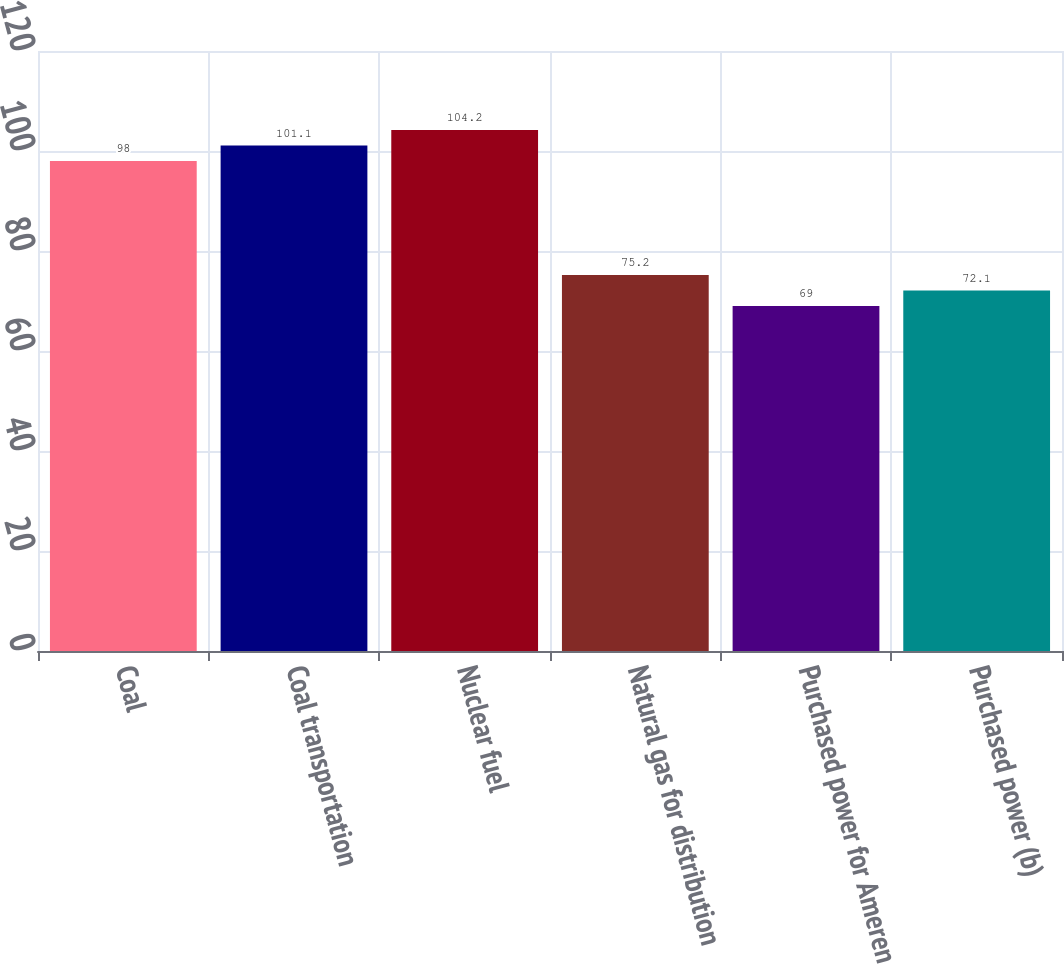Convert chart. <chart><loc_0><loc_0><loc_500><loc_500><bar_chart><fcel>Coal<fcel>Coal transportation<fcel>Nuclear fuel<fcel>Natural gas for distribution<fcel>Purchased power for Ameren<fcel>Purchased power (b)<nl><fcel>98<fcel>101.1<fcel>104.2<fcel>75.2<fcel>69<fcel>72.1<nl></chart> 